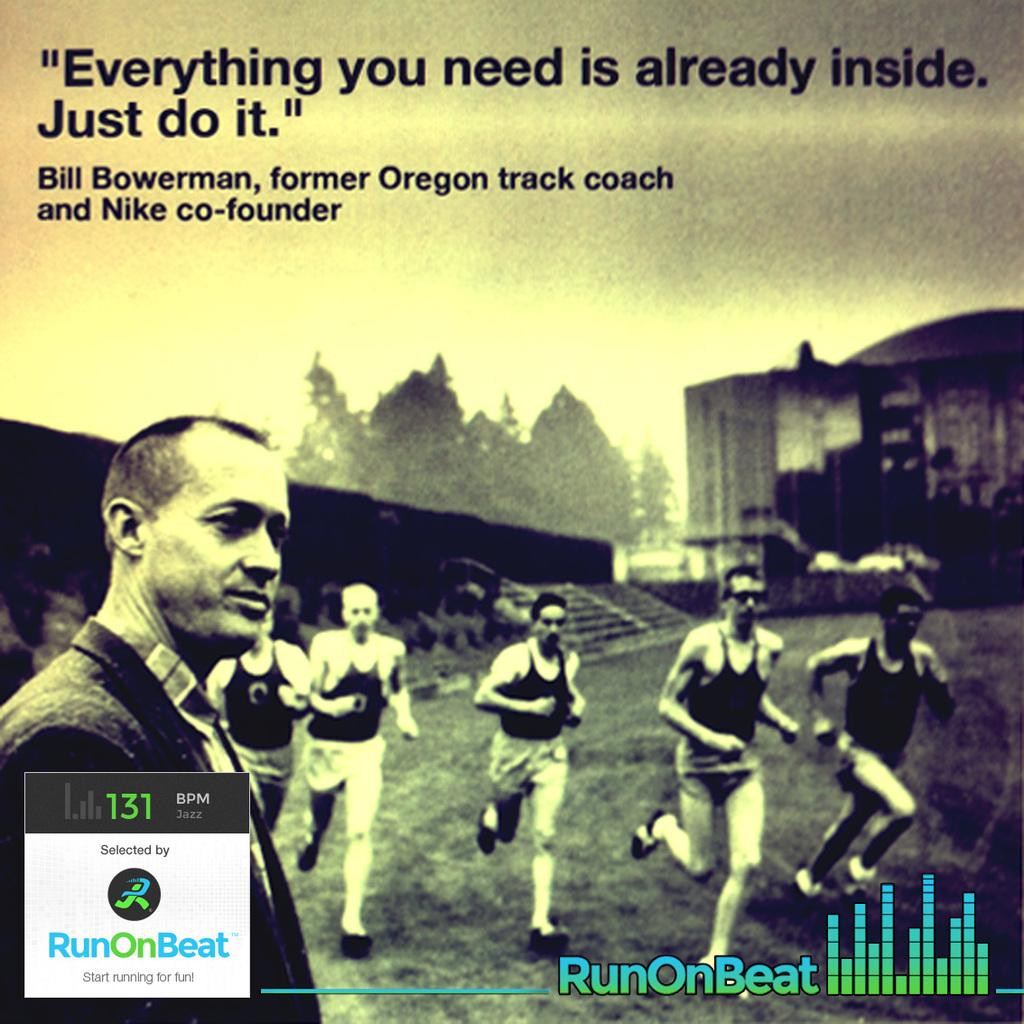What are the persons in the image doing? The persons in the image are running on the ground. Can you describe the person who is not running? There is a person standing in the image. What architectural feature can be seen in the background? There are stairs in the background. What other structures are visible in the background? There are buildings in the background. What type of vegetation is present in the background? There are trees in the background. What part of the natural environment is visible in the image? The sky is visible in the background. What type of cream can be seen on the legs of the persons running in the image? There is no cream visible on the legs of the persons running in the image. How many bikes are being ridden by the persons in the image? There are no bikes present in the image; the persons are running on the ground. 